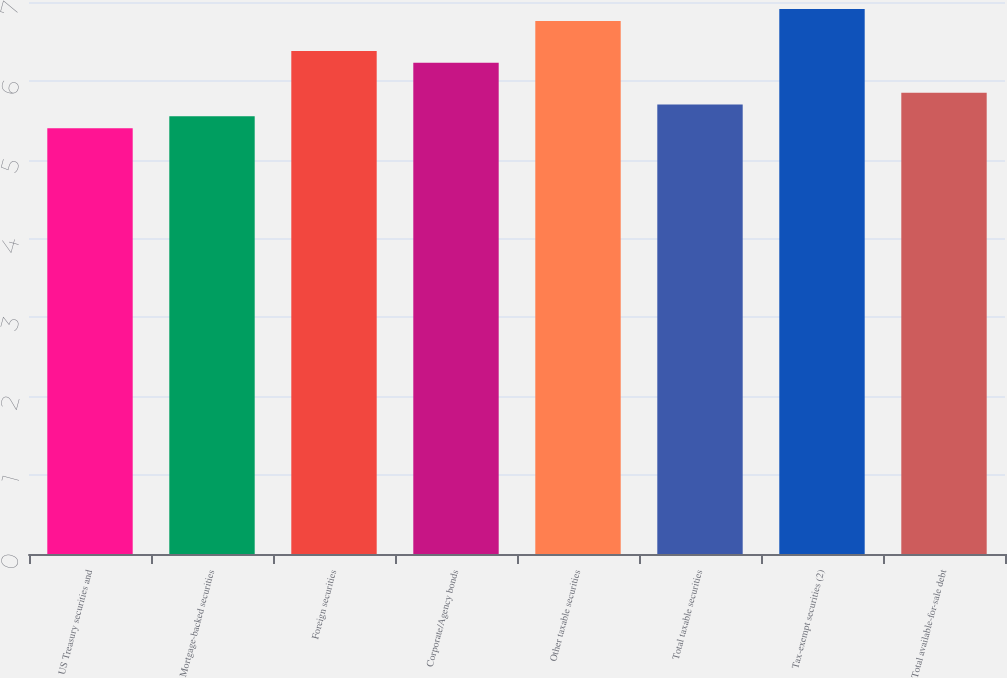Convert chart. <chart><loc_0><loc_0><loc_500><loc_500><bar_chart><fcel>US Treasury securities and<fcel>Mortgage-backed securities<fcel>Foreign securities<fcel>Corporate/Agency bonds<fcel>Other taxable securities<fcel>Total taxable securities<fcel>Tax-exempt securities (2)<fcel>Total available-for-sale debt<nl><fcel>5.4<fcel>5.55<fcel>6.38<fcel>6.23<fcel>6.76<fcel>5.7<fcel>6.91<fcel>5.85<nl></chart> 